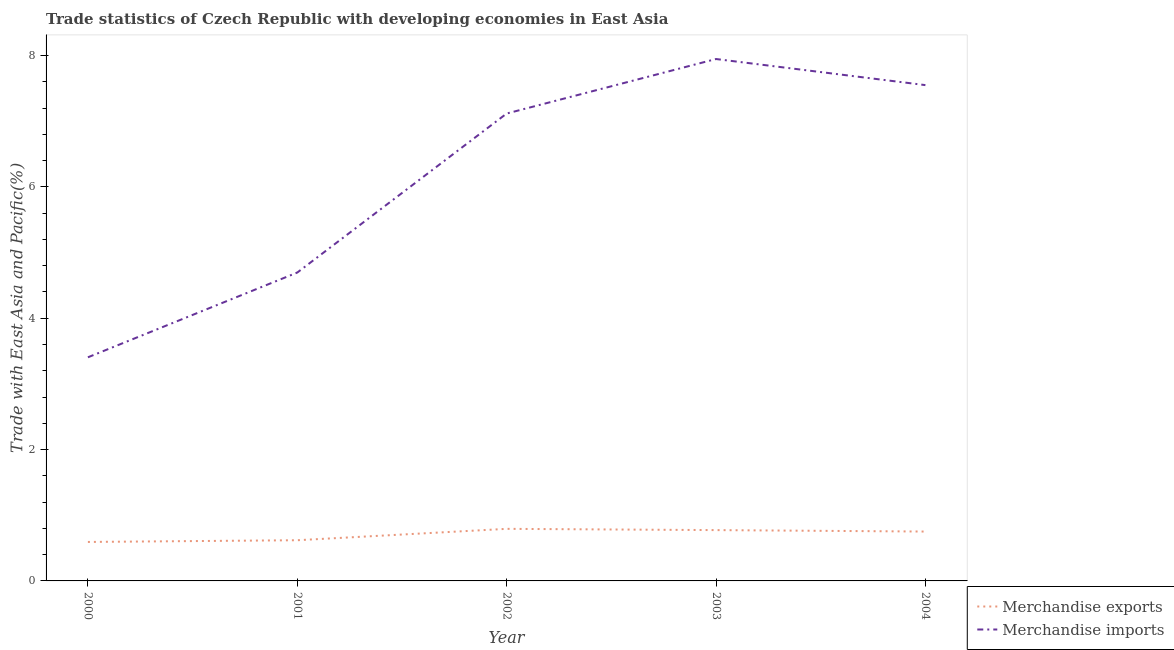What is the merchandise exports in 2002?
Give a very brief answer. 0.79. Across all years, what is the maximum merchandise exports?
Your answer should be very brief. 0.79. Across all years, what is the minimum merchandise imports?
Keep it short and to the point. 3.4. In which year was the merchandise exports maximum?
Provide a short and direct response. 2002. What is the total merchandise imports in the graph?
Your response must be concise. 30.71. What is the difference between the merchandise exports in 2001 and that in 2002?
Offer a terse response. -0.17. What is the difference between the merchandise imports in 2003 and the merchandise exports in 2002?
Give a very brief answer. 7.15. What is the average merchandise exports per year?
Ensure brevity in your answer.  0.71. In the year 2000, what is the difference between the merchandise imports and merchandise exports?
Offer a very short reply. 2.81. In how many years, is the merchandise exports greater than 3.2 %?
Give a very brief answer. 0. What is the ratio of the merchandise imports in 2000 to that in 2002?
Give a very brief answer. 0.48. What is the difference between the highest and the second highest merchandise exports?
Keep it short and to the point. 0.02. What is the difference between the highest and the lowest merchandise exports?
Offer a terse response. 0.2. Is the sum of the merchandise exports in 2000 and 2001 greater than the maximum merchandise imports across all years?
Your answer should be compact. No. Does the merchandise imports monotonically increase over the years?
Your response must be concise. No. Are the values on the major ticks of Y-axis written in scientific E-notation?
Your response must be concise. No. Where does the legend appear in the graph?
Your answer should be very brief. Bottom right. How are the legend labels stacked?
Make the answer very short. Vertical. What is the title of the graph?
Make the answer very short. Trade statistics of Czech Republic with developing economies in East Asia. What is the label or title of the Y-axis?
Provide a succinct answer. Trade with East Asia and Pacific(%). What is the Trade with East Asia and Pacific(%) of Merchandise exports in 2000?
Provide a short and direct response. 0.59. What is the Trade with East Asia and Pacific(%) in Merchandise imports in 2000?
Keep it short and to the point. 3.4. What is the Trade with East Asia and Pacific(%) in Merchandise exports in 2001?
Your answer should be very brief. 0.62. What is the Trade with East Asia and Pacific(%) of Merchandise imports in 2001?
Provide a short and direct response. 4.7. What is the Trade with East Asia and Pacific(%) of Merchandise exports in 2002?
Provide a succinct answer. 0.79. What is the Trade with East Asia and Pacific(%) of Merchandise imports in 2002?
Ensure brevity in your answer.  7.12. What is the Trade with East Asia and Pacific(%) in Merchandise exports in 2003?
Make the answer very short. 0.77. What is the Trade with East Asia and Pacific(%) in Merchandise imports in 2003?
Your answer should be very brief. 7.95. What is the Trade with East Asia and Pacific(%) of Merchandise exports in 2004?
Ensure brevity in your answer.  0.75. What is the Trade with East Asia and Pacific(%) in Merchandise imports in 2004?
Your response must be concise. 7.55. Across all years, what is the maximum Trade with East Asia and Pacific(%) in Merchandise exports?
Offer a terse response. 0.79. Across all years, what is the maximum Trade with East Asia and Pacific(%) in Merchandise imports?
Provide a short and direct response. 7.95. Across all years, what is the minimum Trade with East Asia and Pacific(%) in Merchandise exports?
Keep it short and to the point. 0.59. Across all years, what is the minimum Trade with East Asia and Pacific(%) in Merchandise imports?
Your response must be concise. 3.4. What is the total Trade with East Asia and Pacific(%) in Merchandise exports in the graph?
Give a very brief answer. 3.53. What is the total Trade with East Asia and Pacific(%) of Merchandise imports in the graph?
Your answer should be compact. 30.71. What is the difference between the Trade with East Asia and Pacific(%) in Merchandise exports in 2000 and that in 2001?
Keep it short and to the point. -0.03. What is the difference between the Trade with East Asia and Pacific(%) of Merchandise imports in 2000 and that in 2001?
Keep it short and to the point. -1.29. What is the difference between the Trade with East Asia and Pacific(%) of Merchandise exports in 2000 and that in 2002?
Keep it short and to the point. -0.2. What is the difference between the Trade with East Asia and Pacific(%) of Merchandise imports in 2000 and that in 2002?
Give a very brief answer. -3.71. What is the difference between the Trade with East Asia and Pacific(%) of Merchandise exports in 2000 and that in 2003?
Make the answer very short. -0.18. What is the difference between the Trade with East Asia and Pacific(%) of Merchandise imports in 2000 and that in 2003?
Provide a short and direct response. -4.54. What is the difference between the Trade with East Asia and Pacific(%) in Merchandise exports in 2000 and that in 2004?
Make the answer very short. -0.16. What is the difference between the Trade with East Asia and Pacific(%) in Merchandise imports in 2000 and that in 2004?
Give a very brief answer. -4.14. What is the difference between the Trade with East Asia and Pacific(%) in Merchandise exports in 2001 and that in 2002?
Your response must be concise. -0.17. What is the difference between the Trade with East Asia and Pacific(%) of Merchandise imports in 2001 and that in 2002?
Offer a terse response. -2.42. What is the difference between the Trade with East Asia and Pacific(%) in Merchandise exports in 2001 and that in 2003?
Your response must be concise. -0.15. What is the difference between the Trade with East Asia and Pacific(%) in Merchandise imports in 2001 and that in 2003?
Keep it short and to the point. -3.25. What is the difference between the Trade with East Asia and Pacific(%) of Merchandise exports in 2001 and that in 2004?
Offer a terse response. -0.13. What is the difference between the Trade with East Asia and Pacific(%) of Merchandise imports in 2001 and that in 2004?
Your response must be concise. -2.85. What is the difference between the Trade with East Asia and Pacific(%) in Merchandise exports in 2002 and that in 2003?
Provide a succinct answer. 0.02. What is the difference between the Trade with East Asia and Pacific(%) of Merchandise imports in 2002 and that in 2003?
Make the answer very short. -0.83. What is the difference between the Trade with East Asia and Pacific(%) of Merchandise exports in 2002 and that in 2004?
Make the answer very short. 0.04. What is the difference between the Trade with East Asia and Pacific(%) in Merchandise imports in 2002 and that in 2004?
Your answer should be very brief. -0.43. What is the difference between the Trade with East Asia and Pacific(%) of Merchandise exports in 2003 and that in 2004?
Make the answer very short. 0.02. What is the difference between the Trade with East Asia and Pacific(%) of Merchandise imports in 2003 and that in 2004?
Provide a short and direct response. 0.4. What is the difference between the Trade with East Asia and Pacific(%) in Merchandise exports in 2000 and the Trade with East Asia and Pacific(%) in Merchandise imports in 2001?
Make the answer very short. -4.1. What is the difference between the Trade with East Asia and Pacific(%) of Merchandise exports in 2000 and the Trade with East Asia and Pacific(%) of Merchandise imports in 2002?
Your answer should be compact. -6.52. What is the difference between the Trade with East Asia and Pacific(%) of Merchandise exports in 2000 and the Trade with East Asia and Pacific(%) of Merchandise imports in 2003?
Offer a very short reply. -7.35. What is the difference between the Trade with East Asia and Pacific(%) of Merchandise exports in 2000 and the Trade with East Asia and Pacific(%) of Merchandise imports in 2004?
Your answer should be very brief. -6.96. What is the difference between the Trade with East Asia and Pacific(%) of Merchandise exports in 2001 and the Trade with East Asia and Pacific(%) of Merchandise imports in 2002?
Give a very brief answer. -6.5. What is the difference between the Trade with East Asia and Pacific(%) in Merchandise exports in 2001 and the Trade with East Asia and Pacific(%) in Merchandise imports in 2003?
Your answer should be very brief. -7.33. What is the difference between the Trade with East Asia and Pacific(%) in Merchandise exports in 2001 and the Trade with East Asia and Pacific(%) in Merchandise imports in 2004?
Keep it short and to the point. -6.93. What is the difference between the Trade with East Asia and Pacific(%) in Merchandise exports in 2002 and the Trade with East Asia and Pacific(%) in Merchandise imports in 2003?
Offer a terse response. -7.15. What is the difference between the Trade with East Asia and Pacific(%) of Merchandise exports in 2002 and the Trade with East Asia and Pacific(%) of Merchandise imports in 2004?
Offer a terse response. -6.76. What is the difference between the Trade with East Asia and Pacific(%) of Merchandise exports in 2003 and the Trade with East Asia and Pacific(%) of Merchandise imports in 2004?
Your response must be concise. -6.78. What is the average Trade with East Asia and Pacific(%) in Merchandise exports per year?
Offer a terse response. 0.71. What is the average Trade with East Asia and Pacific(%) of Merchandise imports per year?
Your answer should be compact. 6.14. In the year 2000, what is the difference between the Trade with East Asia and Pacific(%) in Merchandise exports and Trade with East Asia and Pacific(%) in Merchandise imports?
Offer a terse response. -2.81. In the year 2001, what is the difference between the Trade with East Asia and Pacific(%) in Merchandise exports and Trade with East Asia and Pacific(%) in Merchandise imports?
Make the answer very short. -4.08. In the year 2002, what is the difference between the Trade with East Asia and Pacific(%) of Merchandise exports and Trade with East Asia and Pacific(%) of Merchandise imports?
Provide a short and direct response. -6.32. In the year 2003, what is the difference between the Trade with East Asia and Pacific(%) of Merchandise exports and Trade with East Asia and Pacific(%) of Merchandise imports?
Offer a very short reply. -7.17. In the year 2004, what is the difference between the Trade with East Asia and Pacific(%) of Merchandise exports and Trade with East Asia and Pacific(%) of Merchandise imports?
Offer a very short reply. -6.8. What is the ratio of the Trade with East Asia and Pacific(%) in Merchandise exports in 2000 to that in 2001?
Make the answer very short. 0.96. What is the ratio of the Trade with East Asia and Pacific(%) in Merchandise imports in 2000 to that in 2001?
Your answer should be compact. 0.73. What is the ratio of the Trade with East Asia and Pacific(%) of Merchandise exports in 2000 to that in 2002?
Your response must be concise. 0.75. What is the ratio of the Trade with East Asia and Pacific(%) of Merchandise imports in 2000 to that in 2002?
Provide a short and direct response. 0.48. What is the ratio of the Trade with East Asia and Pacific(%) in Merchandise exports in 2000 to that in 2003?
Your answer should be compact. 0.77. What is the ratio of the Trade with East Asia and Pacific(%) in Merchandise imports in 2000 to that in 2003?
Ensure brevity in your answer.  0.43. What is the ratio of the Trade with East Asia and Pacific(%) in Merchandise exports in 2000 to that in 2004?
Make the answer very short. 0.79. What is the ratio of the Trade with East Asia and Pacific(%) of Merchandise imports in 2000 to that in 2004?
Offer a terse response. 0.45. What is the ratio of the Trade with East Asia and Pacific(%) of Merchandise exports in 2001 to that in 2002?
Your answer should be compact. 0.78. What is the ratio of the Trade with East Asia and Pacific(%) of Merchandise imports in 2001 to that in 2002?
Your answer should be very brief. 0.66. What is the ratio of the Trade with East Asia and Pacific(%) of Merchandise exports in 2001 to that in 2003?
Your response must be concise. 0.8. What is the ratio of the Trade with East Asia and Pacific(%) in Merchandise imports in 2001 to that in 2003?
Keep it short and to the point. 0.59. What is the ratio of the Trade with East Asia and Pacific(%) in Merchandise exports in 2001 to that in 2004?
Keep it short and to the point. 0.82. What is the ratio of the Trade with East Asia and Pacific(%) in Merchandise imports in 2001 to that in 2004?
Offer a terse response. 0.62. What is the ratio of the Trade with East Asia and Pacific(%) in Merchandise exports in 2002 to that in 2003?
Offer a very short reply. 1.02. What is the ratio of the Trade with East Asia and Pacific(%) in Merchandise imports in 2002 to that in 2003?
Provide a short and direct response. 0.9. What is the ratio of the Trade with East Asia and Pacific(%) in Merchandise exports in 2002 to that in 2004?
Give a very brief answer. 1.06. What is the ratio of the Trade with East Asia and Pacific(%) in Merchandise imports in 2002 to that in 2004?
Your answer should be compact. 0.94. What is the ratio of the Trade with East Asia and Pacific(%) in Merchandise exports in 2003 to that in 2004?
Your response must be concise. 1.03. What is the ratio of the Trade with East Asia and Pacific(%) in Merchandise imports in 2003 to that in 2004?
Give a very brief answer. 1.05. What is the difference between the highest and the second highest Trade with East Asia and Pacific(%) of Merchandise exports?
Keep it short and to the point. 0.02. What is the difference between the highest and the second highest Trade with East Asia and Pacific(%) of Merchandise imports?
Provide a short and direct response. 0.4. What is the difference between the highest and the lowest Trade with East Asia and Pacific(%) of Merchandise exports?
Provide a succinct answer. 0.2. What is the difference between the highest and the lowest Trade with East Asia and Pacific(%) in Merchandise imports?
Give a very brief answer. 4.54. 